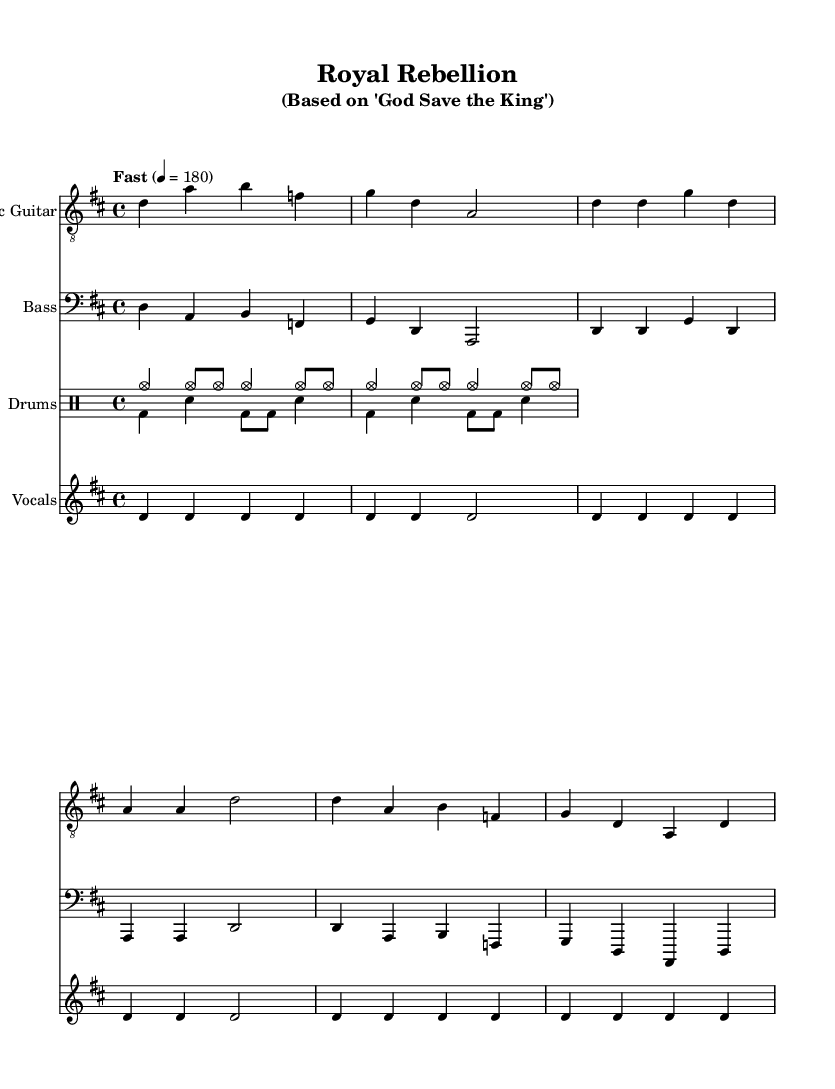What is the key signature of this music? The key signature is D major, indicated at the beginning of the score with two sharps (F# and C#).
Answer: D major What is the time signature of this piece? The time signature is 4/4, shown at the beginning of the score, indicating four beats in each measure with a quarter note receiving one beat.
Answer: 4/4 What is the tempo marking of the piece? The tempo is marked "Fast" with a metronome indication of 180 beats per minute, suggesting a rapid pace for the performance.
Answer: Fast (180) How many measures are in the verse section? The verse contains four measures, as indicated by the repeating structure of the vocal line in the score.
Answer: Four measures What instruments are used in this composition? The instruments include Electric Guitar, Bass, Drums, and Vocals, clearly labeled in the various staves throughout the score.
Answer: Electric Guitar, Bass, Drums, Vocals What is the lyrical theme of the chorus? The chorus presents a rebellious theme against monarchy and advocates for democracy, as expressed in the lyrics "Down with the monarchy, We want democracy."
Answer: Rebellion against monarchy What musical genre does this piece represent? This piece is a Punk composition, noted for its fast tempo, simple harmonic structure, and satirical lyrical content aimed at questioning authority.
Answer: Punk 